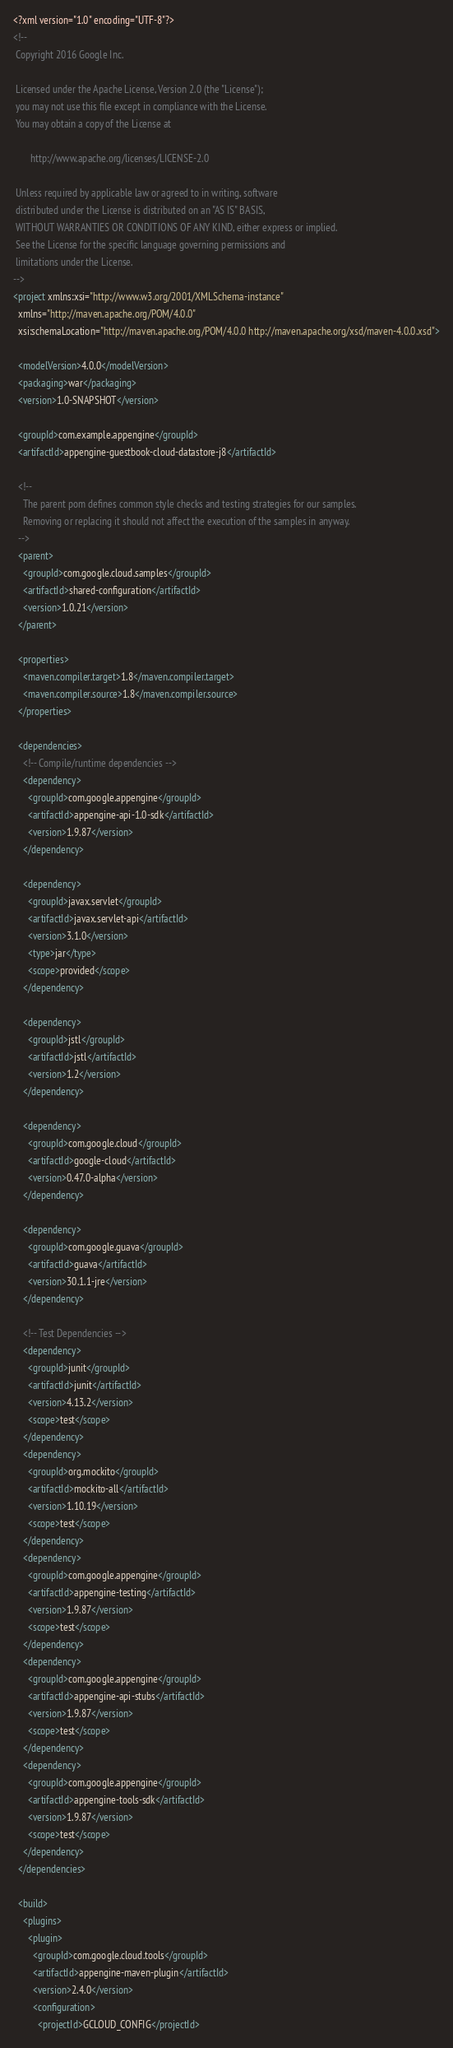Convert code to text. <code><loc_0><loc_0><loc_500><loc_500><_XML_><?xml version="1.0" encoding="UTF-8"?>
<!--
 Copyright 2016 Google Inc.

 Licensed under the Apache License, Version 2.0 (the "License");
 you may not use this file except in compliance with the License.
 You may obtain a copy of the License at

       http://www.apache.org/licenses/LICENSE-2.0

 Unless required by applicable law or agreed to in writing, software
 distributed under the License is distributed on an "AS IS" BASIS,
 WITHOUT WARRANTIES OR CONDITIONS OF ANY KIND, either express or implied.
 See the License for the specific language governing permissions and
 limitations under the License.
-->
<project xmlns:xsi="http://www.w3.org/2001/XMLSchema-instance"
  xmlns="http://maven.apache.org/POM/4.0.0"
  xsi:schemaLocation="http://maven.apache.org/POM/4.0.0 http://maven.apache.org/xsd/maven-4.0.0.xsd">

  <modelVersion>4.0.0</modelVersion>
  <packaging>war</packaging>
  <version>1.0-SNAPSHOT</version>

  <groupId>com.example.appengine</groupId>
  <artifactId>appengine-guestbook-cloud-datastore-j8</artifactId>

  <!--
    The parent pom defines common style checks and testing strategies for our samples.
    Removing or replacing it should not affect the execution of the samples in anyway.
  -->
  <parent>
    <groupId>com.google.cloud.samples</groupId>
    <artifactId>shared-configuration</artifactId>
    <version>1.0.21</version>
  </parent>

  <properties>
    <maven.compiler.target>1.8</maven.compiler.target>
    <maven.compiler.source>1.8</maven.compiler.source>
  </properties>

  <dependencies>
    <!-- Compile/runtime dependencies -->
    <dependency>
      <groupId>com.google.appengine</groupId>
      <artifactId>appengine-api-1.0-sdk</artifactId>
      <version>1.9.87</version>
    </dependency>

    <dependency>
      <groupId>javax.servlet</groupId>
      <artifactId>javax.servlet-api</artifactId>
      <version>3.1.0</version>
      <type>jar</type>
      <scope>provided</scope>
    </dependency>

    <dependency>
      <groupId>jstl</groupId>
      <artifactId>jstl</artifactId>
      <version>1.2</version>
    </dependency>

    <dependency>
      <groupId>com.google.cloud</groupId>
      <artifactId>google-cloud</artifactId>
      <version>0.47.0-alpha</version>
    </dependency>

    <dependency>
      <groupId>com.google.guava</groupId>
      <artifactId>guava</artifactId>
      <version>30.1.1-jre</version>
    </dependency>

    <!-- Test Dependencies -->
    <dependency>
      <groupId>junit</groupId>
      <artifactId>junit</artifactId>
      <version>4.13.2</version>
      <scope>test</scope>
    </dependency>
    <dependency>
      <groupId>org.mockito</groupId>
      <artifactId>mockito-all</artifactId>
      <version>1.10.19</version>
      <scope>test</scope>
    </dependency>
    <dependency>
      <groupId>com.google.appengine</groupId>
      <artifactId>appengine-testing</artifactId>
      <version>1.9.87</version>
      <scope>test</scope>
    </dependency>
    <dependency>
      <groupId>com.google.appengine</groupId>
      <artifactId>appengine-api-stubs</artifactId>
      <version>1.9.87</version>
      <scope>test</scope>
    </dependency>
    <dependency>
      <groupId>com.google.appengine</groupId>
      <artifactId>appengine-tools-sdk</artifactId>
      <version>1.9.87</version>
      <scope>test</scope>
    </dependency>
  </dependencies>

  <build>
    <plugins>
      <plugin>
        <groupId>com.google.cloud.tools</groupId>
        <artifactId>appengine-maven-plugin</artifactId>
        <version>2.4.0</version>
        <configuration>
          <projectId>GCLOUD_CONFIG</projectId></code> 